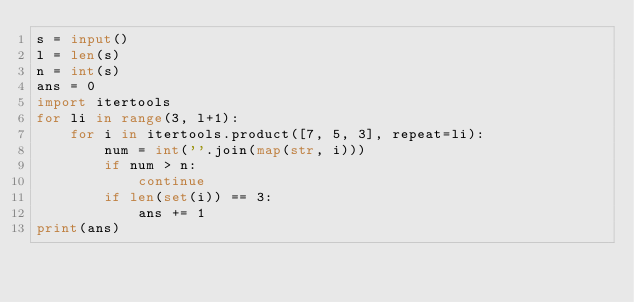<code> <loc_0><loc_0><loc_500><loc_500><_Python_>s = input()
l = len(s)
n = int(s)
ans = 0
import itertools
for li in range(3, l+1):
    for i in itertools.product([7, 5, 3], repeat=li):
        num = int(''.join(map(str, i)))
        if num > n:
            continue
        if len(set(i)) == 3:
            ans += 1
print(ans)</code> 